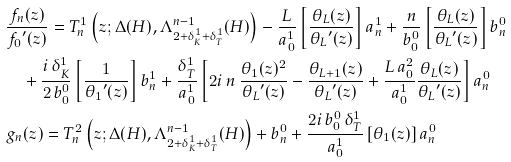<formula> <loc_0><loc_0><loc_500><loc_500>& \frac { f _ { n } ( z ) } { { f _ { 0 } } ^ { \prime } ( z ) } = T _ { n } ^ { 1 } \left ( z ; \Delta ( H ) , \Lambda ^ { n - 1 } _ { 2 + \delta ^ { 1 } _ { K } + \delta ^ { 1 } _ { T } } ( H ) \right ) - \frac { L } { a _ { 0 } ^ { 1 } } \left [ \frac { \theta _ { L } ( z ) } { { \theta _ { L } } ^ { \prime } ( z ) } \right ] a _ { n } ^ { 1 } + \frac { n } { b _ { 0 } ^ { 0 } } \left [ \frac { \theta _ { L } ( z ) } { { \theta _ { L } } ^ { \prime } ( z ) } \right ] b _ { n } ^ { 0 } \\ & \quad + \frac { i \, \delta ^ { 1 } _ { K } } { 2 \, b _ { 0 } ^ { 0 } } \left [ \frac { 1 } { { \theta _ { 1 } } ^ { \prime } ( z ) } \right ] b _ { n } ^ { 1 } + \frac { \delta ^ { 1 } _ { T } } { a _ { 0 } ^ { 1 } } \left [ 2 i \, n \, \frac { \theta _ { 1 } ( z ) ^ { 2 } } { { \theta _ { L } } ^ { \prime } ( z ) } - \frac { \theta _ { L + 1 } ( z ) } { { \theta _ { L } } ^ { \prime } ( z ) } + \frac { L \, a _ { 0 } ^ { 2 } } { a _ { 0 } ^ { 1 } } \frac { \theta _ { L } ( z ) } { { \theta _ { L } } ^ { \prime } ( z ) } \right ] a _ { n } ^ { 0 } \\ & g _ { n } ( z ) = T _ { n } ^ { 2 } \left ( z ; \Delta ( H ) , \Lambda ^ { n - 1 } _ { 2 + \delta ^ { 1 } _ { K } + \delta ^ { 1 } _ { T } } ( H ) \right ) + b _ { n } ^ { 0 } + \frac { 2 i \, b _ { 0 } ^ { 0 } \, \delta ^ { 1 } _ { T } } { a _ { 0 } ^ { 1 } } \left [ \theta _ { 1 } ( z ) \right ] a _ { n } ^ { 0 }</formula> 